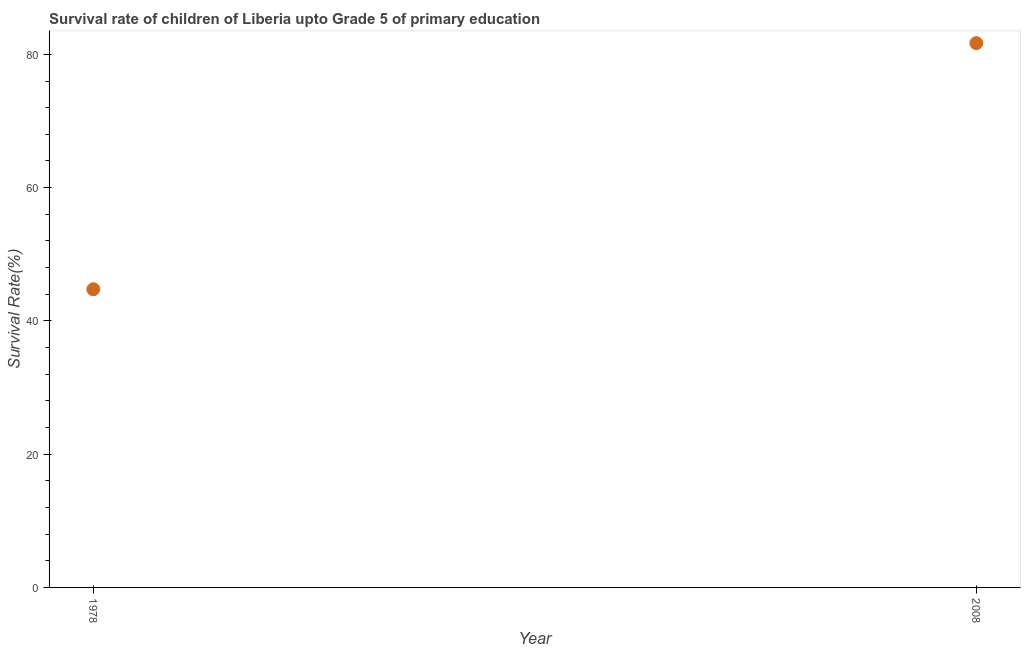What is the survival rate in 1978?
Your response must be concise. 44.75. Across all years, what is the maximum survival rate?
Provide a short and direct response. 81.69. Across all years, what is the minimum survival rate?
Your response must be concise. 44.75. In which year was the survival rate maximum?
Give a very brief answer. 2008. In which year was the survival rate minimum?
Your answer should be compact. 1978. What is the sum of the survival rate?
Your response must be concise. 126.44. What is the difference between the survival rate in 1978 and 2008?
Make the answer very short. -36.94. What is the average survival rate per year?
Make the answer very short. 63.22. What is the median survival rate?
Ensure brevity in your answer.  63.22. In how many years, is the survival rate greater than 52 %?
Give a very brief answer. 1. What is the ratio of the survival rate in 1978 to that in 2008?
Give a very brief answer. 0.55. Is the survival rate in 1978 less than that in 2008?
Offer a very short reply. Yes. How many dotlines are there?
Give a very brief answer. 1. How many years are there in the graph?
Your answer should be very brief. 2. What is the difference between two consecutive major ticks on the Y-axis?
Keep it short and to the point. 20. Are the values on the major ticks of Y-axis written in scientific E-notation?
Ensure brevity in your answer.  No. What is the title of the graph?
Your answer should be compact. Survival rate of children of Liberia upto Grade 5 of primary education. What is the label or title of the Y-axis?
Ensure brevity in your answer.  Survival Rate(%). What is the Survival Rate(%) in 1978?
Offer a terse response. 44.75. What is the Survival Rate(%) in 2008?
Provide a succinct answer. 81.69. What is the difference between the Survival Rate(%) in 1978 and 2008?
Your answer should be compact. -36.94. What is the ratio of the Survival Rate(%) in 1978 to that in 2008?
Give a very brief answer. 0.55. 